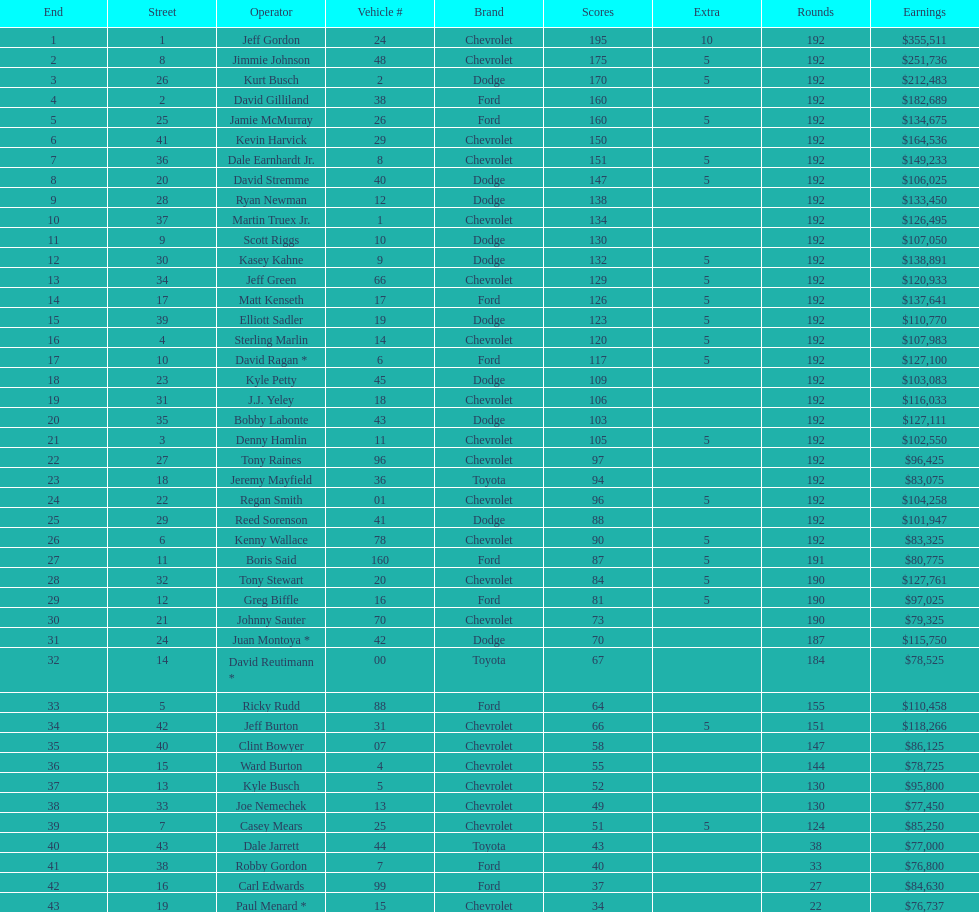Who is first in number of winnings on this list? Jeff Gordon. Would you mind parsing the complete table? {'header': ['End', 'Street', 'Operator', 'Vehicle #', 'Brand', 'Scores', 'Extra', 'Rounds', 'Earnings'], 'rows': [['1', '1', 'Jeff Gordon', '24', 'Chevrolet', '195', '10', '192', '$355,511'], ['2', '8', 'Jimmie Johnson', '48', 'Chevrolet', '175', '5', '192', '$251,736'], ['3', '26', 'Kurt Busch', '2', 'Dodge', '170', '5', '192', '$212,483'], ['4', '2', 'David Gilliland', '38', 'Ford', '160', '', '192', '$182,689'], ['5', '25', 'Jamie McMurray', '26', 'Ford', '160', '5', '192', '$134,675'], ['6', '41', 'Kevin Harvick', '29', 'Chevrolet', '150', '', '192', '$164,536'], ['7', '36', 'Dale Earnhardt Jr.', '8', 'Chevrolet', '151', '5', '192', '$149,233'], ['8', '20', 'David Stremme', '40', 'Dodge', '147', '5', '192', '$106,025'], ['9', '28', 'Ryan Newman', '12', 'Dodge', '138', '', '192', '$133,450'], ['10', '37', 'Martin Truex Jr.', '1', 'Chevrolet', '134', '', '192', '$126,495'], ['11', '9', 'Scott Riggs', '10', 'Dodge', '130', '', '192', '$107,050'], ['12', '30', 'Kasey Kahne', '9', 'Dodge', '132', '5', '192', '$138,891'], ['13', '34', 'Jeff Green', '66', 'Chevrolet', '129', '5', '192', '$120,933'], ['14', '17', 'Matt Kenseth', '17', 'Ford', '126', '5', '192', '$137,641'], ['15', '39', 'Elliott Sadler', '19', 'Dodge', '123', '5', '192', '$110,770'], ['16', '4', 'Sterling Marlin', '14', 'Chevrolet', '120', '5', '192', '$107,983'], ['17', '10', 'David Ragan *', '6', 'Ford', '117', '5', '192', '$127,100'], ['18', '23', 'Kyle Petty', '45', 'Dodge', '109', '', '192', '$103,083'], ['19', '31', 'J.J. Yeley', '18', 'Chevrolet', '106', '', '192', '$116,033'], ['20', '35', 'Bobby Labonte', '43', 'Dodge', '103', '', '192', '$127,111'], ['21', '3', 'Denny Hamlin', '11', 'Chevrolet', '105', '5', '192', '$102,550'], ['22', '27', 'Tony Raines', '96', 'Chevrolet', '97', '', '192', '$96,425'], ['23', '18', 'Jeremy Mayfield', '36', 'Toyota', '94', '', '192', '$83,075'], ['24', '22', 'Regan Smith', '01', 'Chevrolet', '96', '5', '192', '$104,258'], ['25', '29', 'Reed Sorenson', '41', 'Dodge', '88', '', '192', '$101,947'], ['26', '6', 'Kenny Wallace', '78', 'Chevrolet', '90', '5', '192', '$83,325'], ['27', '11', 'Boris Said', '160', 'Ford', '87', '5', '191', '$80,775'], ['28', '32', 'Tony Stewart', '20', 'Chevrolet', '84', '5', '190', '$127,761'], ['29', '12', 'Greg Biffle', '16', 'Ford', '81', '5', '190', '$97,025'], ['30', '21', 'Johnny Sauter', '70', 'Chevrolet', '73', '', '190', '$79,325'], ['31', '24', 'Juan Montoya *', '42', 'Dodge', '70', '', '187', '$115,750'], ['32', '14', 'David Reutimann *', '00', 'Toyota', '67', '', '184', '$78,525'], ['33', '5', 'Ricky Rudd', '88', 'Ford', '64', '', '155', '$110,458'], ['34', '42', 'Jeff Burton', '31', 'Chevrolet', '66', '5', '151', '$118,266'], ['35', '40', 'Clint Bowyer', '07', 'Chevrolet', '58', '', '147', '$86,125'], ['36', '15', 'Ward Burton', '4', 'Chevrolet', '55', '', '144', '$78,725'], ['37', '13', 'Kyle Busch', '5', 'Chevrolet', '52', '', '130', '$95,800'], ['38', '33', 'Joe Nemechek', '13', 'Chevrolet', '49', '', '130', '$77,450'], ['39', '7', 'Casey Mears', '25', 'Chevrolet', '51', '5', '124', '$85,250'], ['40', '43', 'Dale Jarrett', '44', 'Toyota', '43', '', '38', '$77,000'], ['41', '38', 'Robby Gordon', '7', 'Ford', '40', '', '33', '$76,800'], ['42', '16', 'Carl Edwards', '99', 'Ford', '37', '', '27', '$84,630'], ['43', '19', 'Paul Menard *', '15', 'Chevrolet', '34', '', '22', '$76,737']]} 